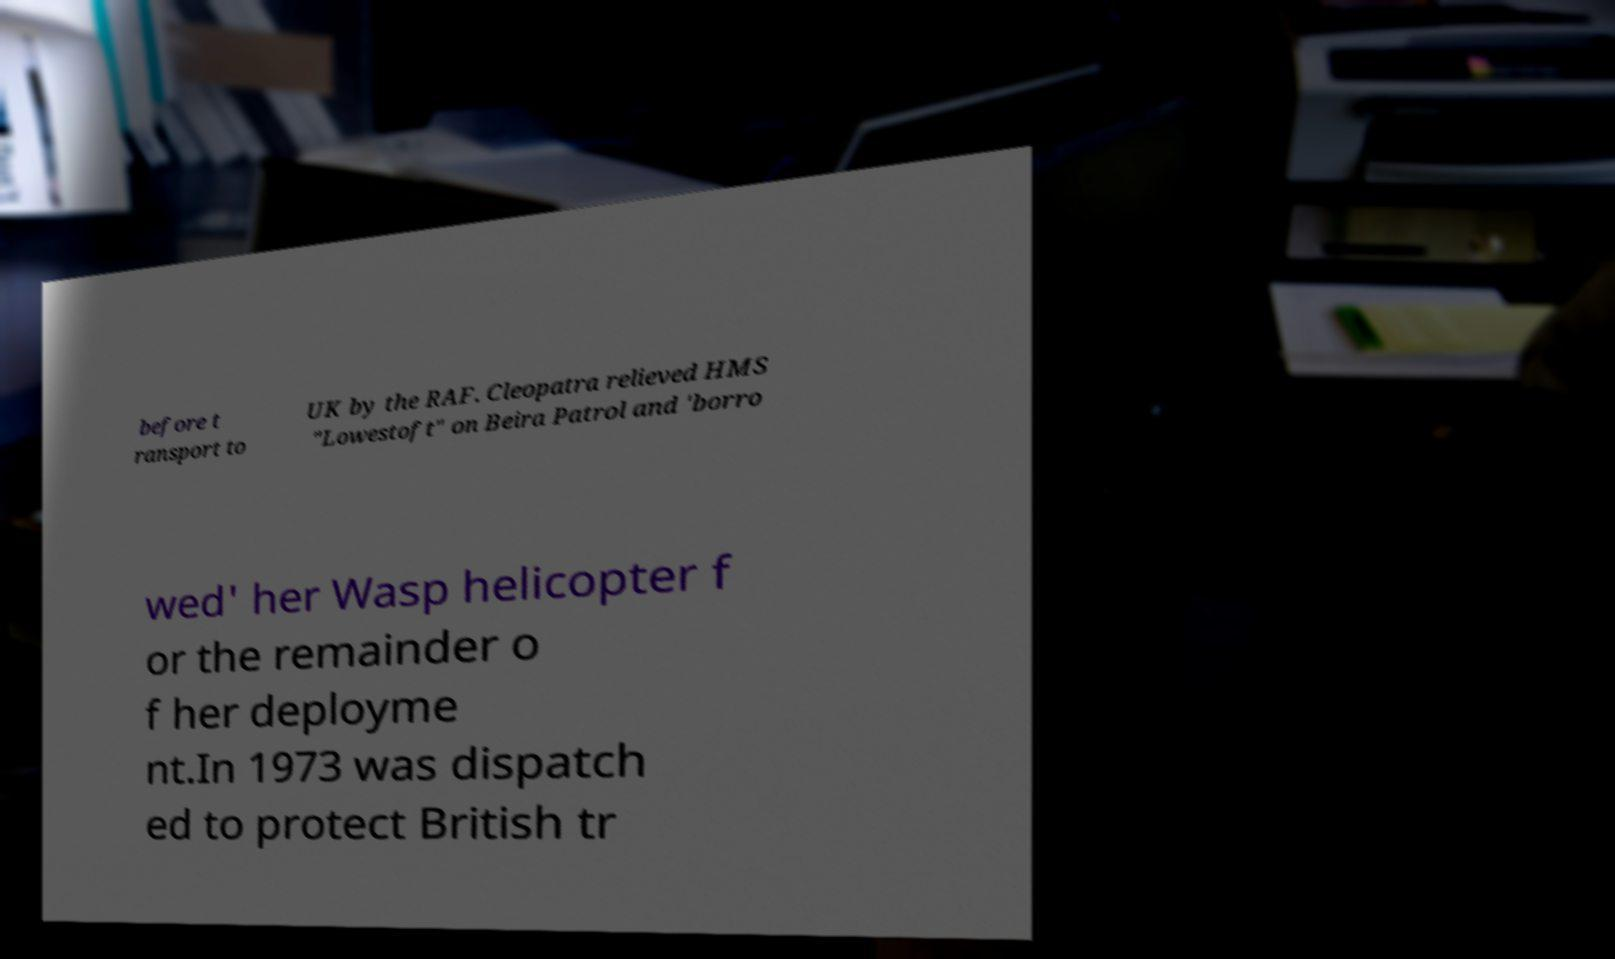I need the written content from this picture converted into text. Can you do that? before t ransport to UK by the RAF. Cleopatra relieved HMS "Lowestoft" on Beira Patrol and 'borro wed' her Wasp helicopter f or the remainder o f her deployme nt.In 1973 was dispatch ed to protect British tr 